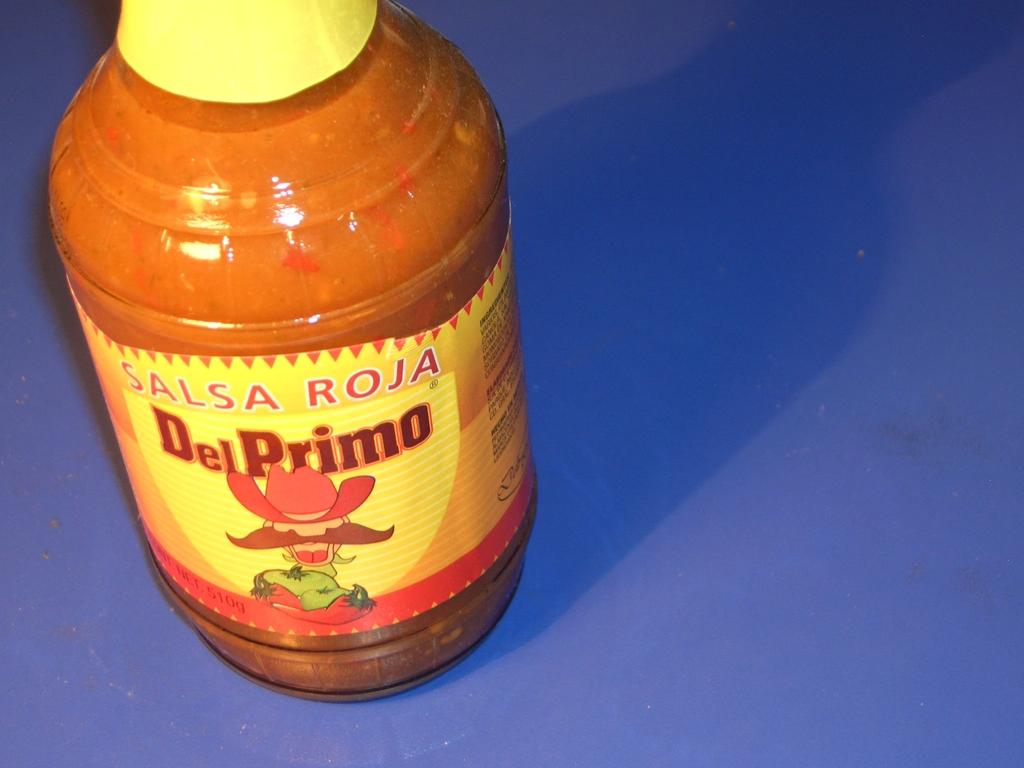Provide a one-sentence caption for the provided image. A jar of Salsa Roja Del Primo sits on a blue surface. 